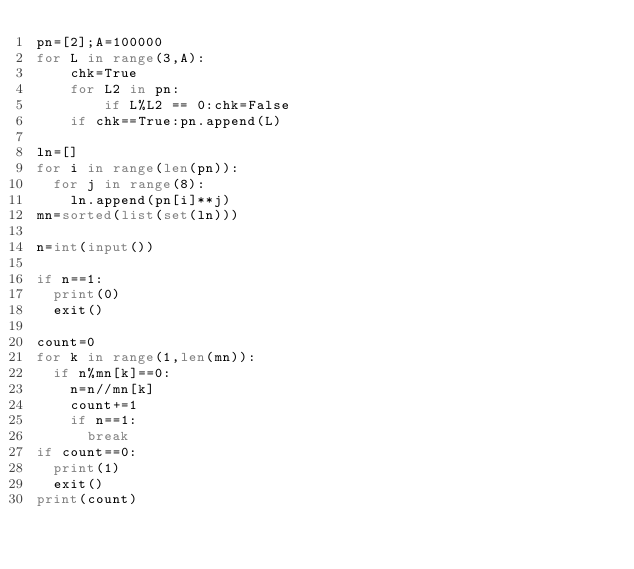Convert code to text. <code><loc_0><loc_0><loc_500><loc_500><_Python_>pn=[2];A=100000
for L in range(3,A):
    chk=True
    for L2 in pn:
        if L%L2 == 0:chk=False
    if chk==True:pn.append(L)
      
ln=[]
for i in range(len(pn)):
  for j in range(8):
    ln.append(pn[i]**j)
mn=sorted(list(set(ln)))

n=int(input())

if n==1:
  print(0)
  exit()

count=0
for k in range(1,len(mn)):
  if n%mn[k]==0:
    n=n//mn[k]
    count+=1
    if n==1:
      break
if count==0:
  print(1)
  exit()
print(count)
</code> 